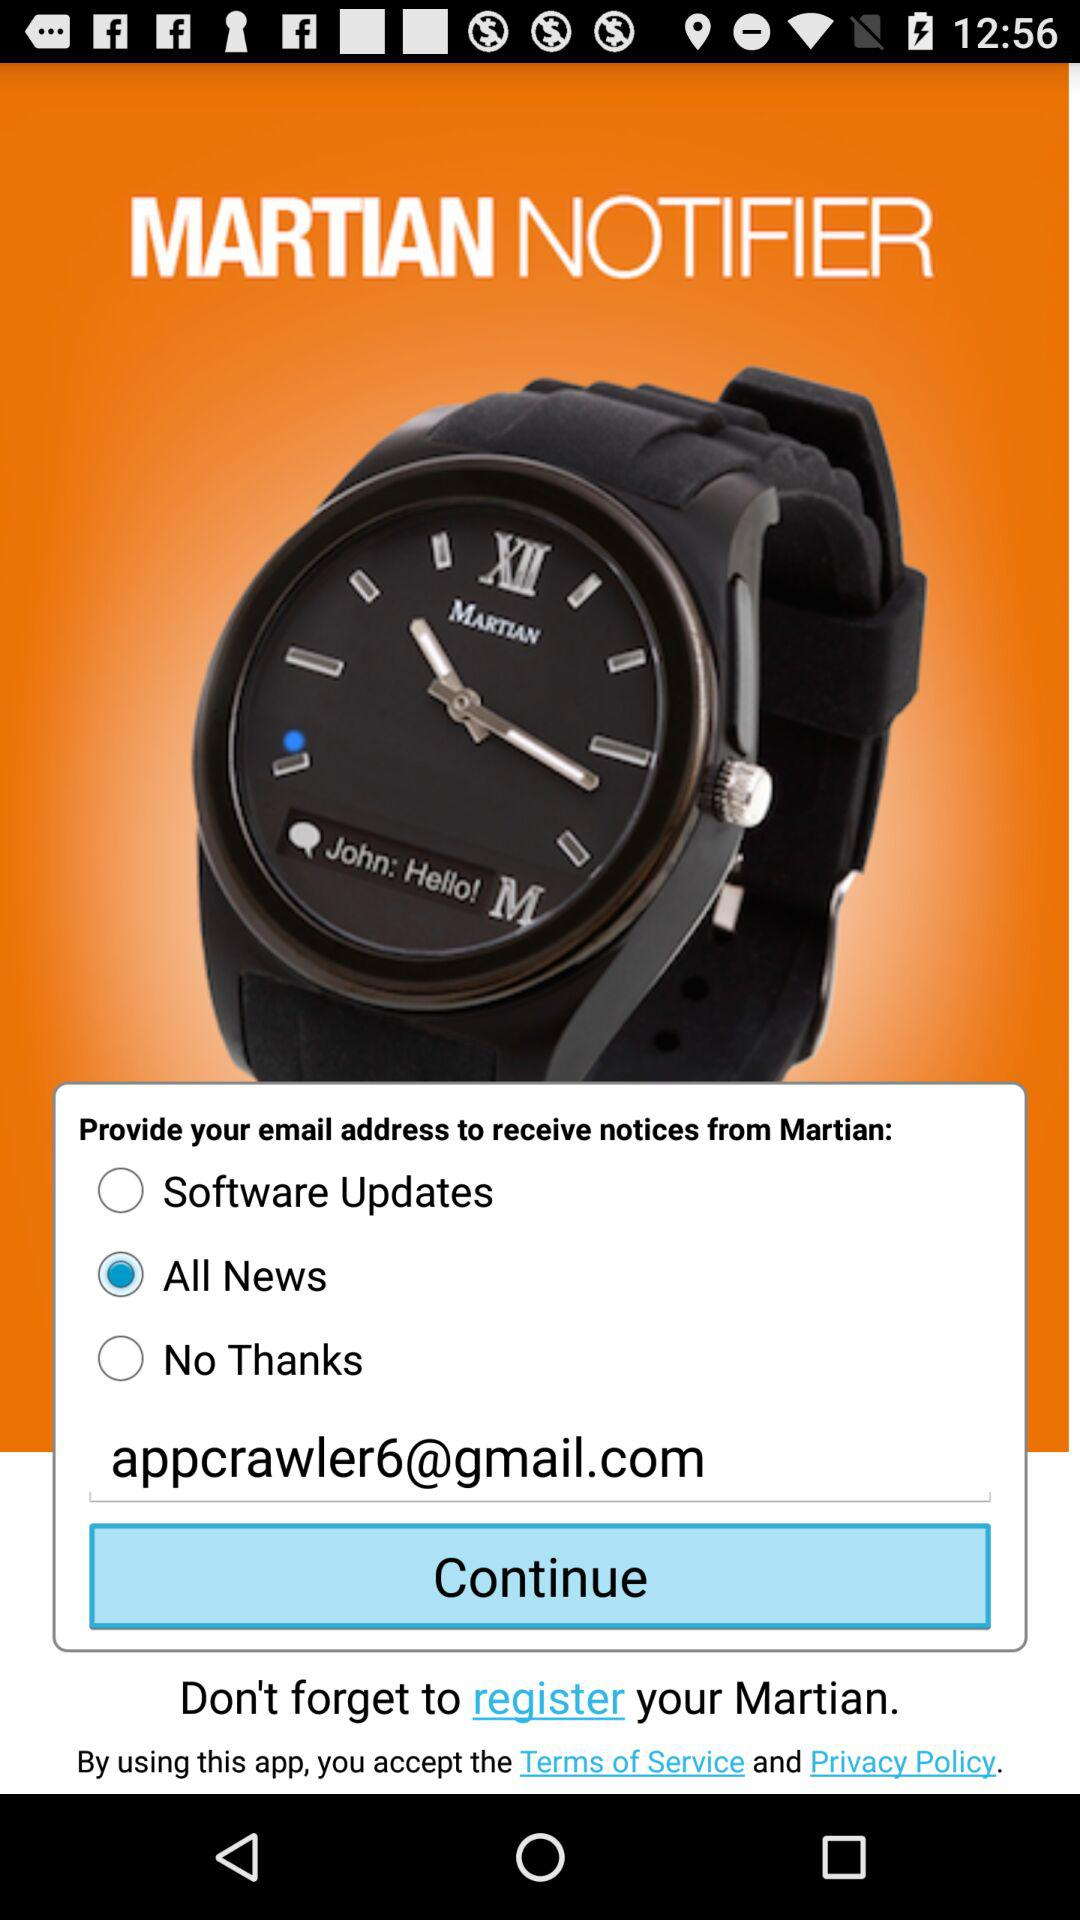How many email options are available?
Answer the question using a single word or phrase. 3 